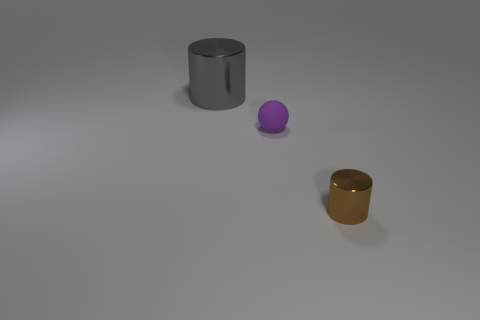Add 3 tiny blue blocks. How many objects exist? 6 Subtract all spheres. How many objects are left? 2 Subtract all red shiny cubes. Subtract all metal cylinders. How many objects are left? 1 Add 2 purple rubber objects. How many purple rubber objects are left? 3 Add 1 gray metal objects. How many gray metal objects exist? 2 Subtract 1 gray cylinders. How many objects are left? 2 Subtract all cyan balls. Subtract all blue cylinders. How many balls are left? 1 